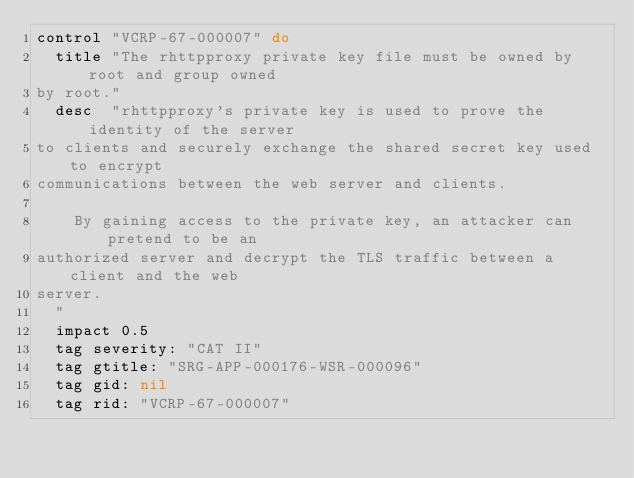Convert code to text. <code><loc_0><loc_0><loc_500><loc_500><_Ruby_>control "VCRP-67-000007" do
  title "The rhttpproxy private key file must be owned by root and group owned
by root."
  desc  "rhttpproxy's private key is used to prove the identity of the server
to clients and securely exchange the shared secret key used to encrypt
communications between the web server and clients.

    By gaining access to the private key, an attacker can pretend to be an
authorized server and decrypt the TLS traffic between a client and the web
server.
  "
  impact 0.5
  tag severity: "CAT II"
  tag gtitle: "SRG-APP-000176-WSR-000096"
  tag gid: nil
  tag rid: "VCRP-67-000007"</code> 